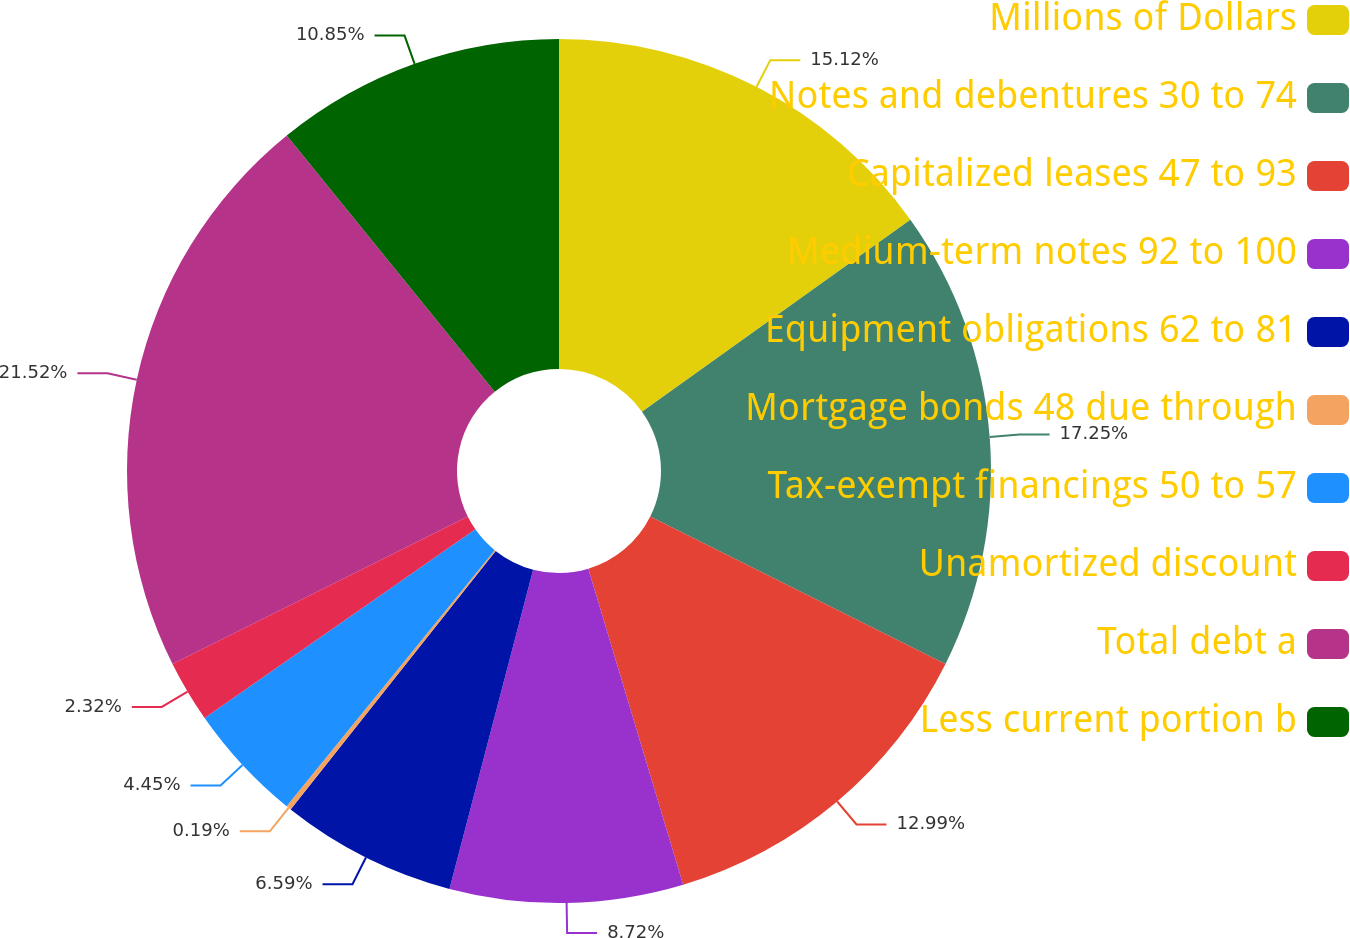<chart> <loc_0><loc_0><loc_500><loc_500><pie_chart><fcel>Millions of Dollars<fcel>Notes and debentures 30 to 74<fcel>Capitalized leases 47 to 93<fcel>Medium-term notes 92 to 100<fcel>Equipment obligations 62 to 81<fcel>Mortgage bonds 48 due through<fcel>Tax-exempt financings 50 to 57<fcel>Unamortized discount<fcel>Total debt a<fcel>Less current portion b<nl><fcel>15.12%<fcel>17.25%<fcel>12.99%<fcel>8.72%<fcel>6.59%<fcel>0.19%<fcel>4.45%<fcel>2.32%<fcel>21.52%<fcel>10.85%<nl></chart> 